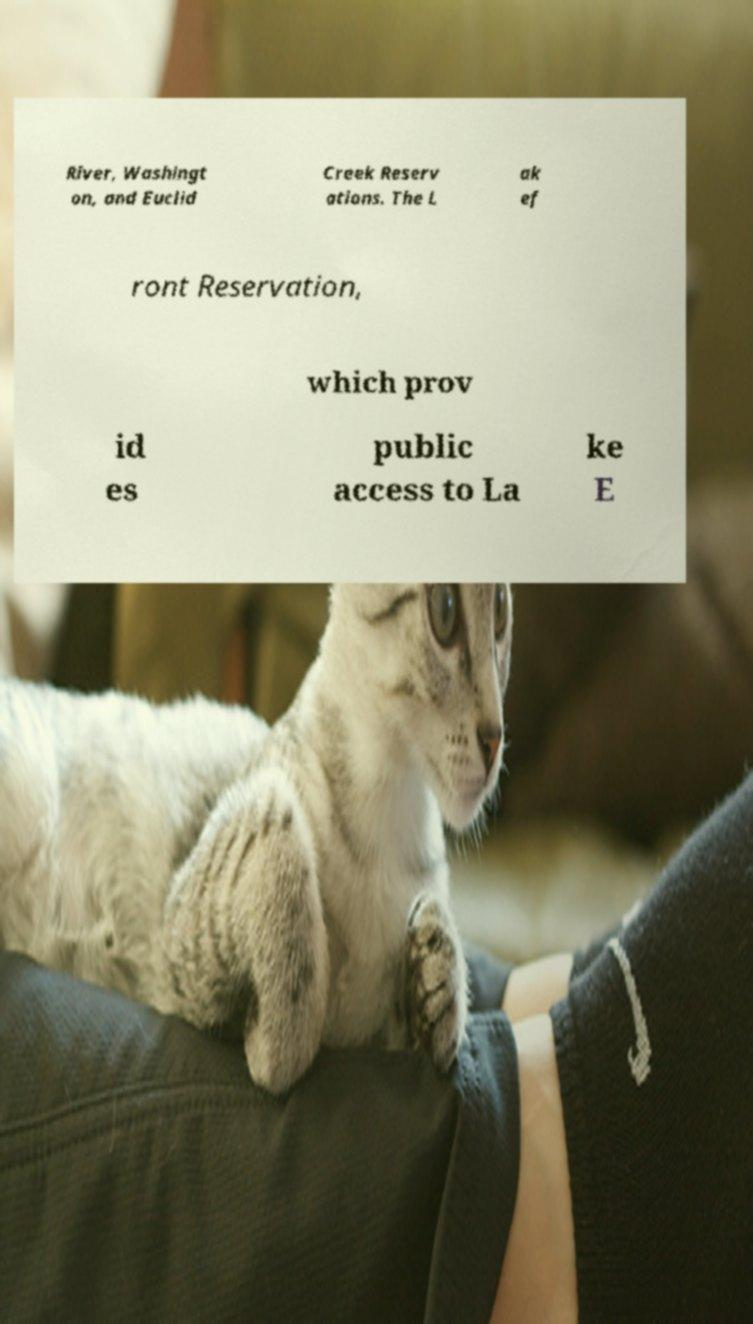Can you accurately transcribe the text from the provided image for me? River, Washingt on, and Euclid Creek Reserv ations. The L ak ef ront Reservation, which prov id es public access to La ke E 